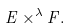<formula> <loc_0><loc_0><loc_500><loc_500>E \times ^ { \lambda } F .</formula> 